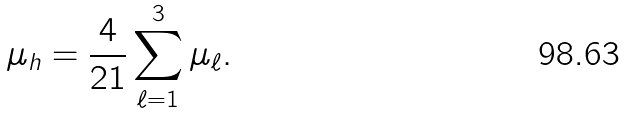<formula> <loc_0><loc_0><loc_500><loc_500>\mu _ { h } = \frac { 4 } { 2 1 } \sum _ { \ell = 1 } ^ { 3 } \mu _ { \ell } .</formula> 